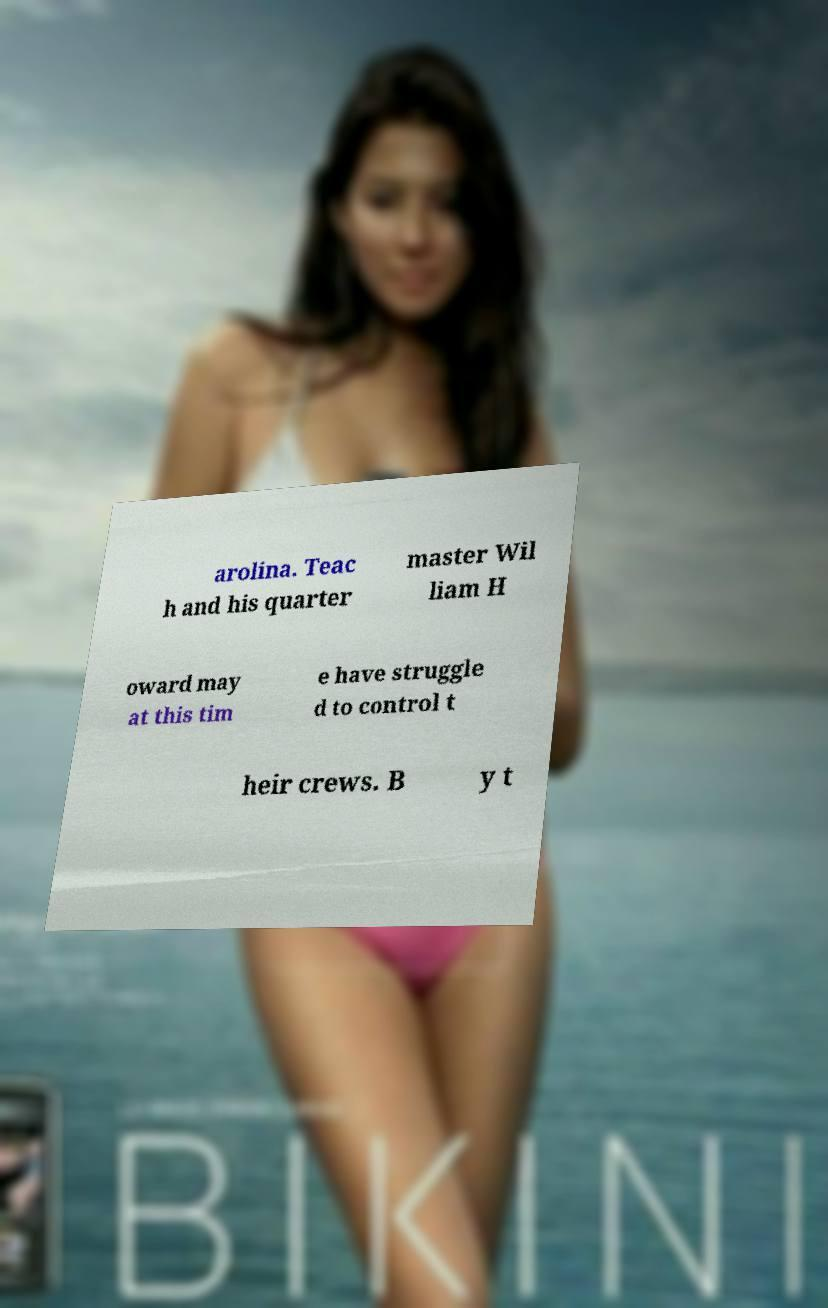There's text embedded in this image that I need extracted. Can you transcribe it verbatim? arolina. Teac h and his quarter master Wil liam H oward may at this tim e have struggle d to control t heir crews. B y t 